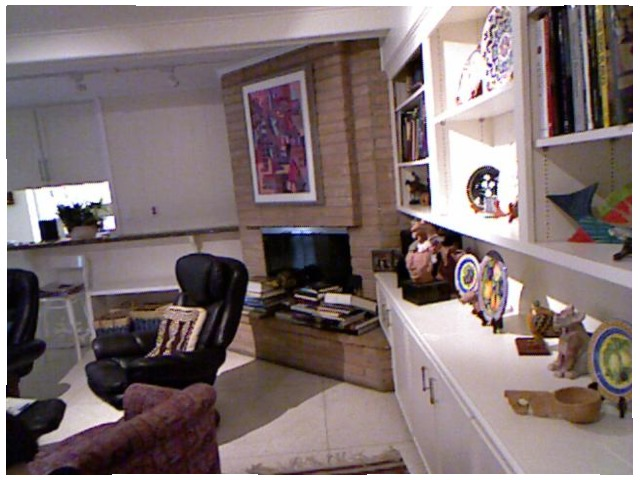<image>
Is the books in front of the chair? No. The books is not in front of the chair. The spatial positioning shows a different relationship between these objects. 